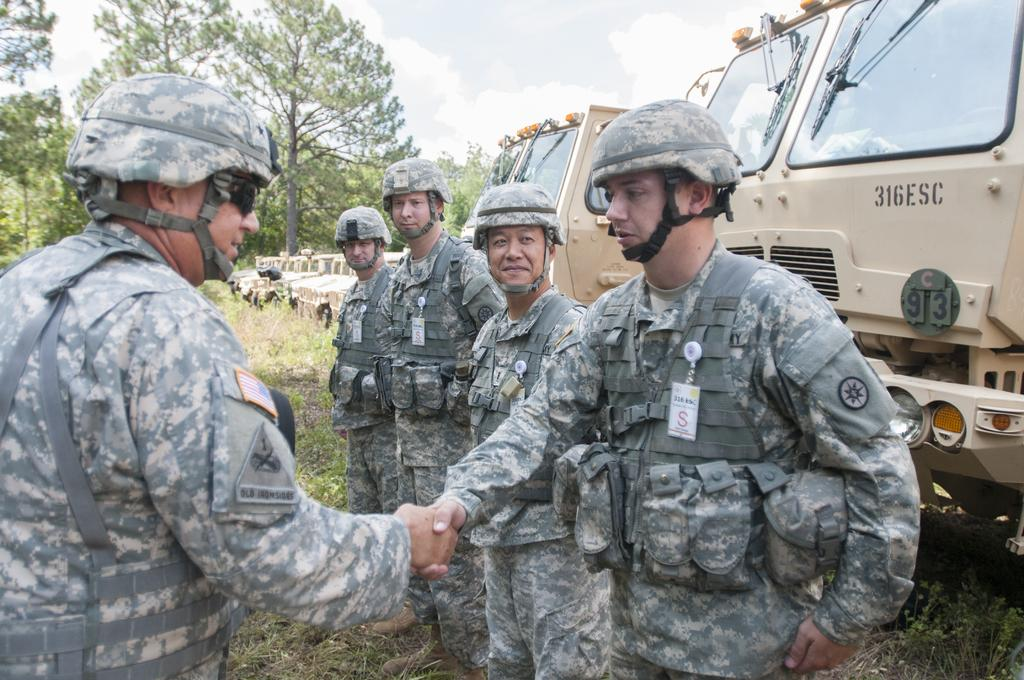Provide a one-sentence caption for the provided image. In a line of military personnel a soldier is being greeted in front of a military tuck numbered 316ESC. 